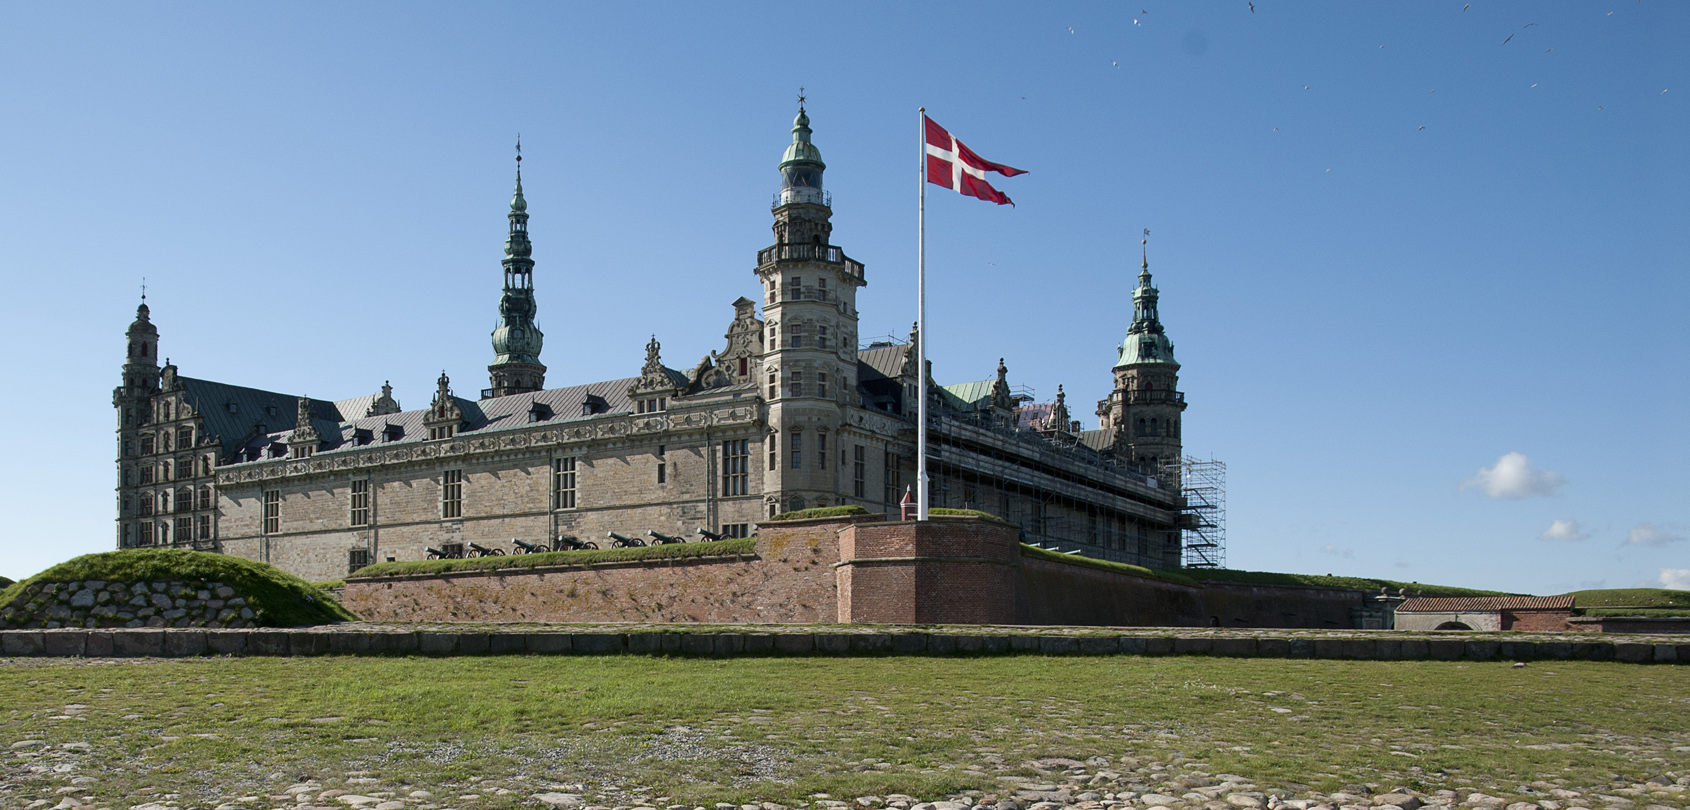What can visitors expect when they visit this castle today? Visitors to Kronborg Castle can explore a variety of exhibits and experiences that bring history to life. They can tour the grand halls where Shakespeare's Hamlet is set, walk through the king’s and queen’s chambers, and visit the chapel with its beautiful woodwork. The castle's fortifications and cannons offer insights into its military history. Interactive exhibits include the Casemates, underground passages used as soldier quarters and storerooms. Additionally, the castle hosts live performances, reenactments, and events that make the visit a dynamic and educational experience. 